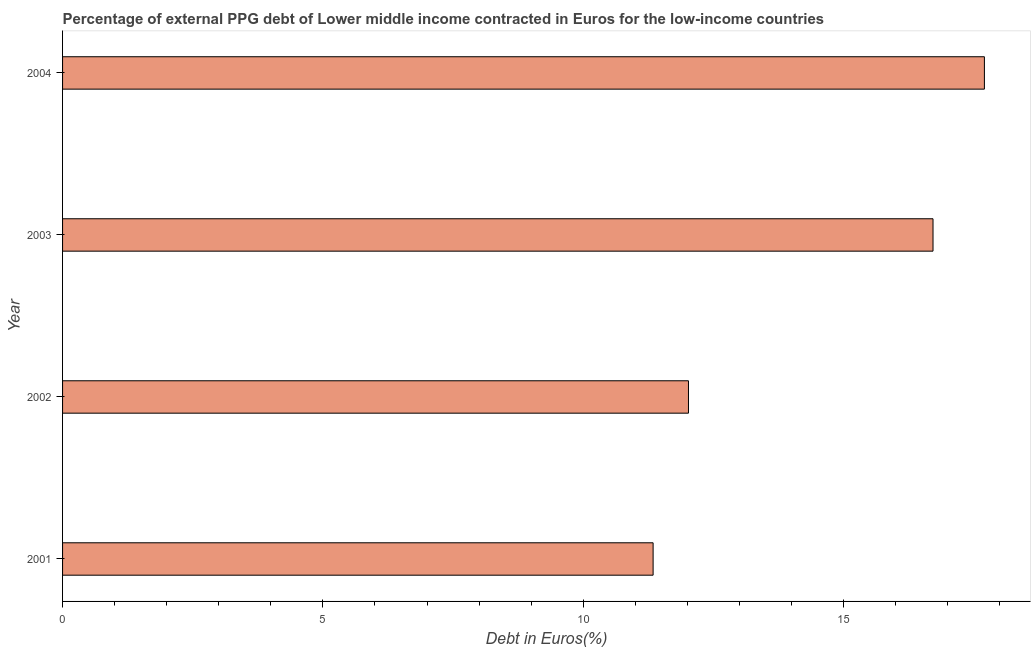What is the title of the graph?
Make the answer very short. Percentage of external PPG debt of Lower middle income contracted in Euros for the low-income countries. What is the label or title of the X-axis?
Give a very brief answer. Debt in Euros(%). What is the label or title of the Y-axis?
Ensure brevity in your answer.  Year. What is the currency composition of ppg debt in 2003?
Keep it short and to the point. 16.72. Across all years, what is the maximum currency composition of ppg debt?
Keep it short and to the point. 17.71. Across all years, what is the minimum currency composition of ppg debt?
Give a very brief answer. 11.34. In which year was the currency composition of ppg debt minimum?
Provide a succinct answer. 2001. What is the sum of the currency composition of ppg debt?
Make the answer very short. 57.79. What is the difference between the currency composition of ppg debt in 2002 and 2003?
Keep it short and to the point. -4.7. What is the average currency composition of ppg debt per year?
Your answer should be very brief. 14.45. What is the median currency composition of ppg debt?
Keep it short and to the point. 14.37. Do a majority of the years between 2003 and 2001 (inclusive) have currency composition of ppg debt greater than 7 %?
Offer a terse response. Yes. What is the ratio of the currency composition of ppg debt in 2001 to that in 2002?
Offer a very short reply. 0.94. Is the difference between the currency composition of ppg debt in 2001 and 2002 greater than the difference between any two years?
Provide a succinct answer. No. Is the sum of the currency composition of ppg debt in 2001 and 2002 greater than the maximum currency composition of ppg debt across all years?
Give a very brief answer. Yes. What is the difference between the highest and the lowest currency composition of ppg debt?
Keep it short and to the point. 6.36. In how many years, is the currency composition of ppg debt greater than the average currency composition of ppg debt taken over all years?
Your response must be concise. 2. How many years are there in the graph?
Provide a succinct answer. 4. What is the difference between two consecutive major ticks on the X-axis?
Keep it short and to the point. 5. Are the values on the major ticks of X-axis written in scientific E-notation?
Your answer should be very brief. No. What is the Debt in Euros(%) in 2001?
Your answer should be compact. 11.34. What is the Debt in Euros(%) of 2002?
Your answer should be very brief. 12.02. What is the Debt in Euros(%) in 2003?
Keep it short and to the point. 16.72. What is the Debt in Euros(%) of 2004?
Keep it short and to the point. 17.71. What is the difference between the Debt in Euros(%) in 2001 and 2002?
Keep it short and to the point. -0.68. What is the difference between the Debt in Euros(%) in 2001 and 2003?
Your response must be concise. -5.38. What is the difference between the Debt in Euros(%) in 2001 and 2004?
Ensure brevity in your answer.  -6.36. What is the difference between the Debt in Euros(%) in 2002 and 2003?
Offer a terse response. -4.7. What is the difference between the Debt in Euros(%) in 2002 and 2004?
Your answer should be compact. -5.68. What is the difference between the Debt in Euros(%) in 2003 and 2004?
Offer a very short reply. -0.99. What is the ratio of the Debt in Euros(%) in 2001 to that in 2002?
Your answer should be very brief. 0.94. What is the ratio of the Debt in Euros(%) in 2001 to that in 2003?
Keep it short and to the point. 0.68. What is the ratio of the Debt in Euros(%) in 2001 to that in 2004?
Provide a succinct answer. 0.64. What is the ratio of the Debt in Euros(%) in 2002 to that in 2003?
Your answer should be very brief. 0.72. What is the ratio of the Debt in Euros(%) in 2002 to that in 2004?
Provide a succinct answer. 0.68. What is the ratio of the Debt in Euros(%) in 2003 to that in 2004?
Give a very brief answer. 0.94. 